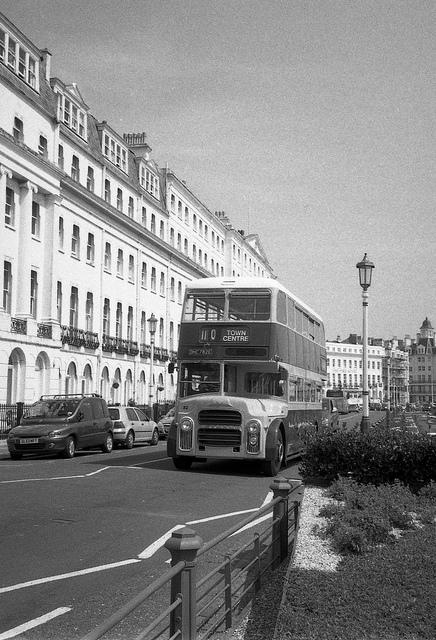Is this picture in color?
Answer briefly. No. What type of bus is this?
Keep it brief. Double decker. What vehicle is parked on the street?
Short answer required. Car. Does this bus have only one level?
Be succinct. No. Is there a ball pictured?
Answer briefly. No. What alliterative phrase refers to an activity regarding transportation of this vehicle?
Keep it brief. Double decker. What color is the bus?
Give a very brief answer. Black and white. 